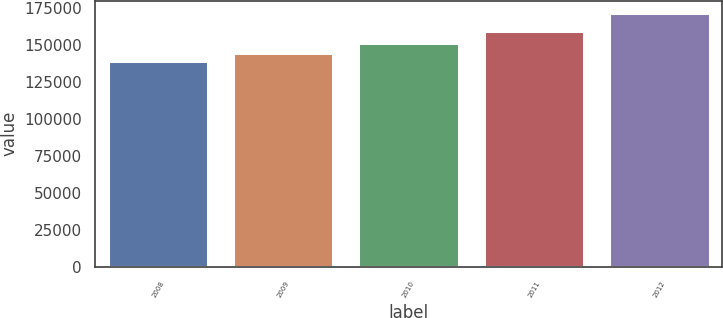<chart> <loc_0><loc_0><loc_500><loc_500><bar_chart><fcel>2008<fcel>2009<fcel>2010<fcel>2011<fcel>2012<nl><fcel>138942<fcel>144468<fcel>150929<fcel>159494<fcel>171302<nl></chart> 